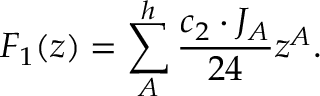Convert formula to latex. <formula><loc_0><loc_0><loc_500><loc_500>F _ { 1 } ( z ) = \sum _ { A } ^ { h } { \frac { c _ { 2 } \cdot J _ { A } } { 2 4 } } z ^ { A } .</formula> 